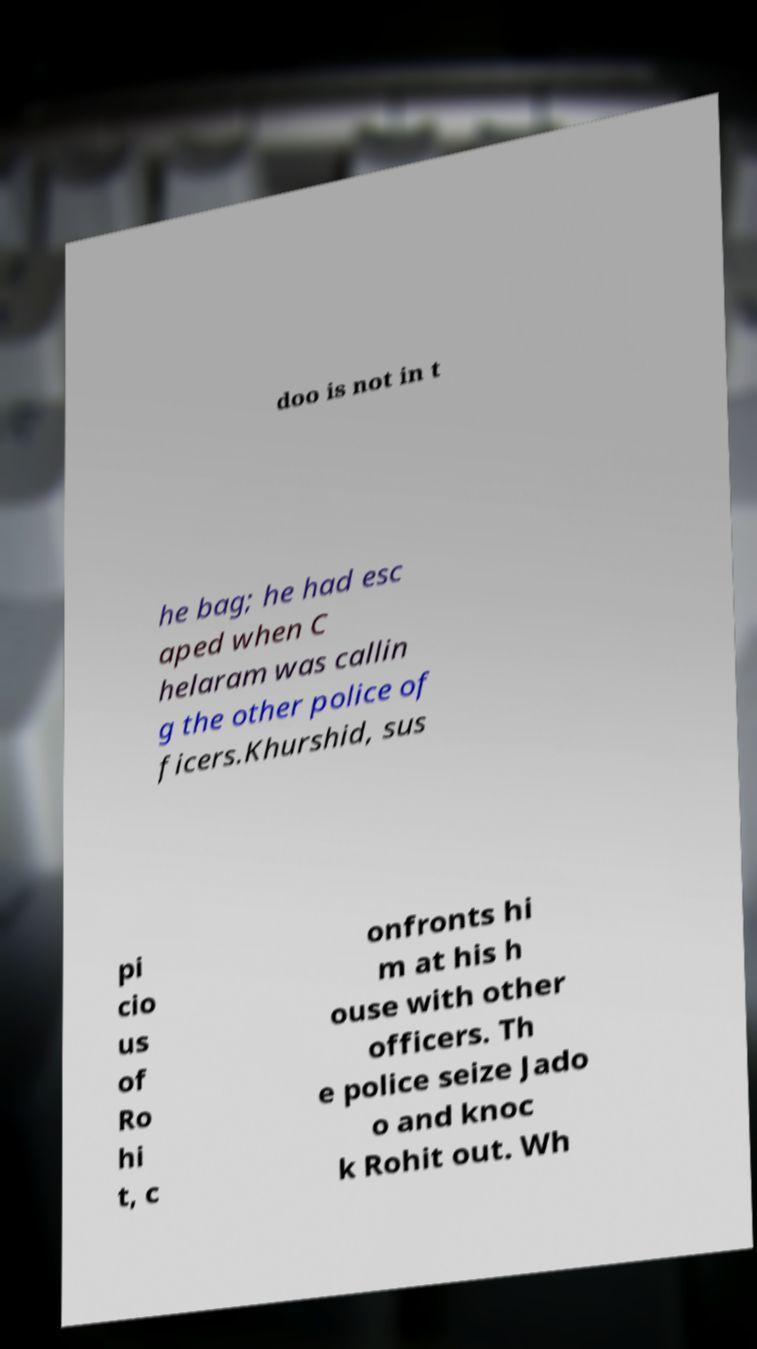Please read and relay the text visible in this image. What does it say? doo is not in t he bag; he had esc aped when C helaram was callin g the other police of ficers.Khurshid, sus pi cio us of Ro hi t, c onfronts hi m at his h ouse with other officers. Th e police seize Jado o and knoc k Rohit out. Wh 